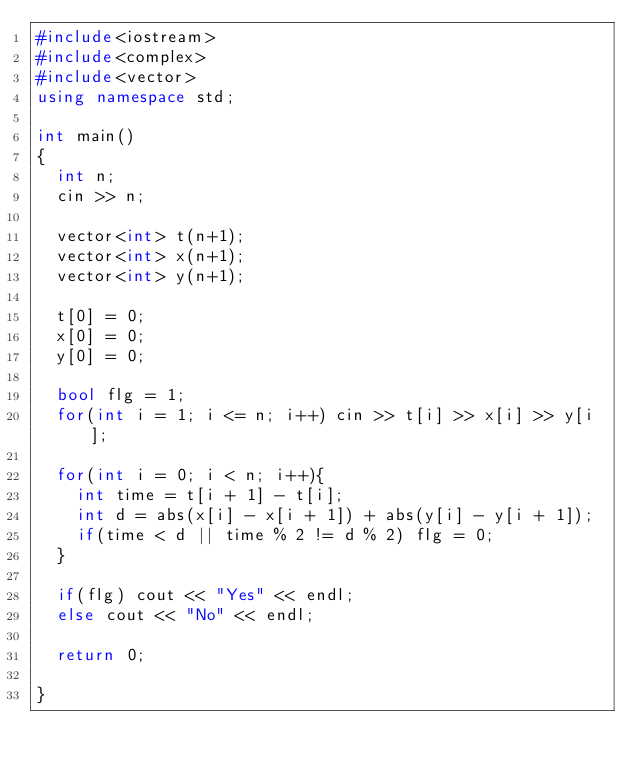<code> <loc_0><loc_0><loc_500><loc_500><_C++_>#include<iostream>
#include<complex>
#include<vector>
using namespace std;

int main()
{
  int n;
  cin >> n;

  vector<int> t(n+1);
  vector<int> x(n+1);
  vector<int> y(n+1);

  t[0] = 0;
  x[0] = 0;
  y[0] = 0;

  bool flg = 1;
  for(int i = 1; i <= n; i++) cin >> t[i] >> x[i] >> y[i];

  for(int i = 0; i < n; i++){
    int time = t[i + 1] - t[i];
    int d = abs(x[i] - x[i + 1]) + abs(y[i] - y[i + 1]);
    if(time < d || time % 2 != d % 2) flg = 0;
  }

  if(flg) cout << "Yes" << endl;
  else cout << "No" << endl;

  return 0;

}

</code> 